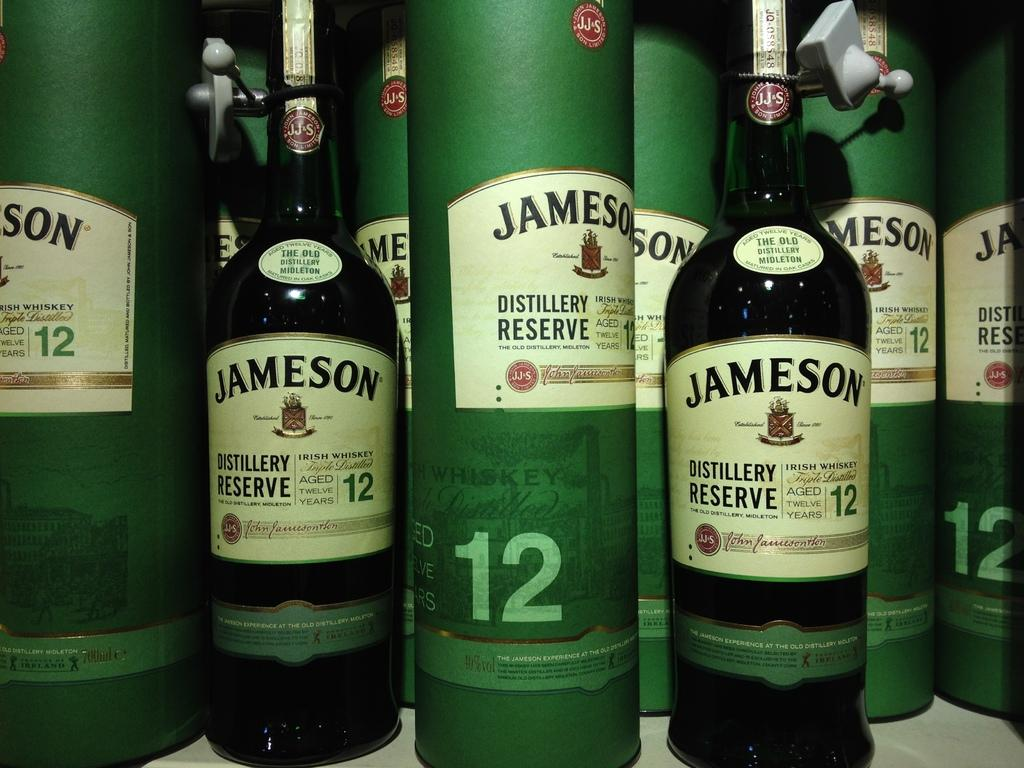What type of beverage containers are present in the image? There are wine bottles in the image. What other objects can be seen in the image? There are green boxes in the image. Are there any additional features on the green boxes? Yes, stickers are attached to the boxes. What type of pancake is being used to stitch the hall in the image? There is no pancake or hall present in the image, and therefore no such activity can be observed. 